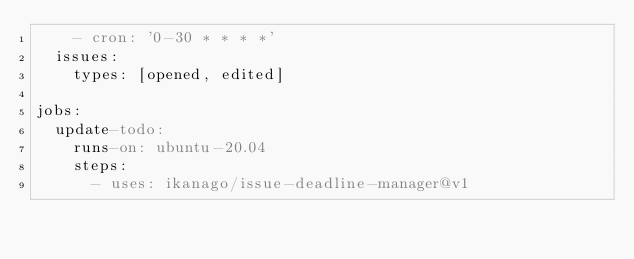<code> <loc_0><loc_0><loc_500><loc_500><_YAML_>    - cron: '0-30 * * * *'
  issues:
    types: [opened, edited]

jobs:
  update-todo:
    runs-on: ubuntu-20.04
    steps:
      - uses: ikanago/issue-deadline-manager@v1
</code> 